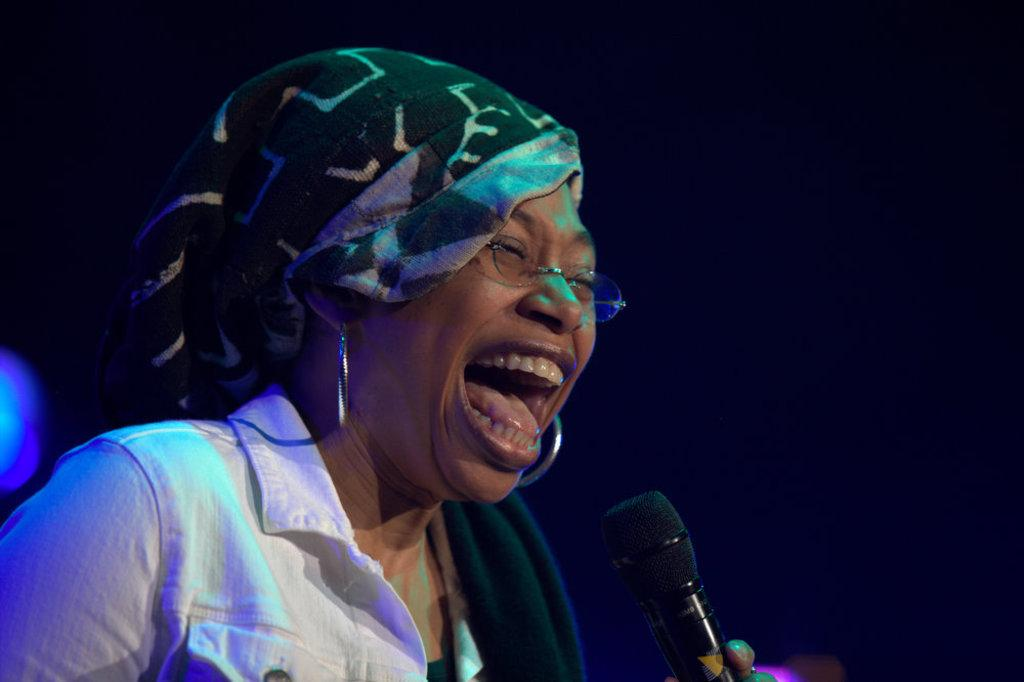Who is the main subject in the image? There is a woman in the image. What is the woman holding in the image? The woman is holding a microphone. What is the woman doing in the image? The woman is screaming. What is the woman wearing in the image? The woman is wearing a white shirt. What is on the woman's head in the image? There is cloth on her head. How would you describe the background of the image? The background of the image appears dark. What grade does the woman receive for her performance in the image? There is no indication of a performance or grading system in the image, so it cannot be determined. 